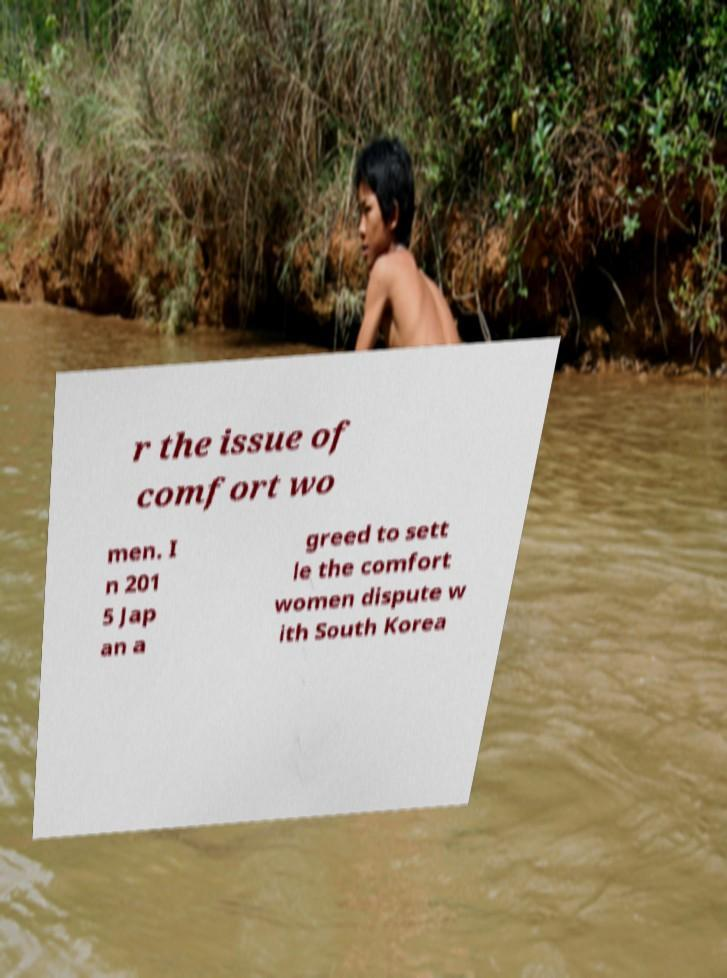Could you assist in decoding the text presented in this image and type it out clearly? r the issue of comfort wo men. I n 201 5 Jap an a greed to sett le the comfort women dispute w ith South Korea 